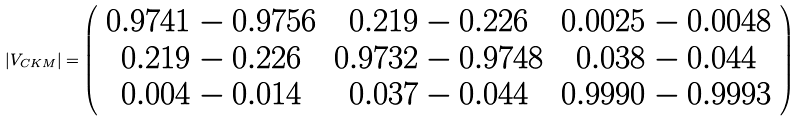Convert formula to latex. <formula><loc_0><loc_0><loc_500><loc_500>| V _ { C K M } | = \left ( \begin{array} { c c c } 0 . 9 7 4 1 - 0 . 9 7 5 6 & 0 . 2 1 9 - 0 . 2 2 6 & 0 . 0 0 2 5 - 0 . 0 0 4 8 \\ 0 . 2 1 9 - 0 . 2 2 6 & 0 . 9 7 3 2 - 0 . 9 7 4 8 & 0 . 0 3 8 - 0 . 0 4 4 \\ 0 . 0 0 4 - 0 . 0 1 4 & 0 . 0 3 7 - 0 . 0 4 4 & 0 . 9 9 9 0 - 0 . 9 9 9 3 \end{array} \right )</formula> 